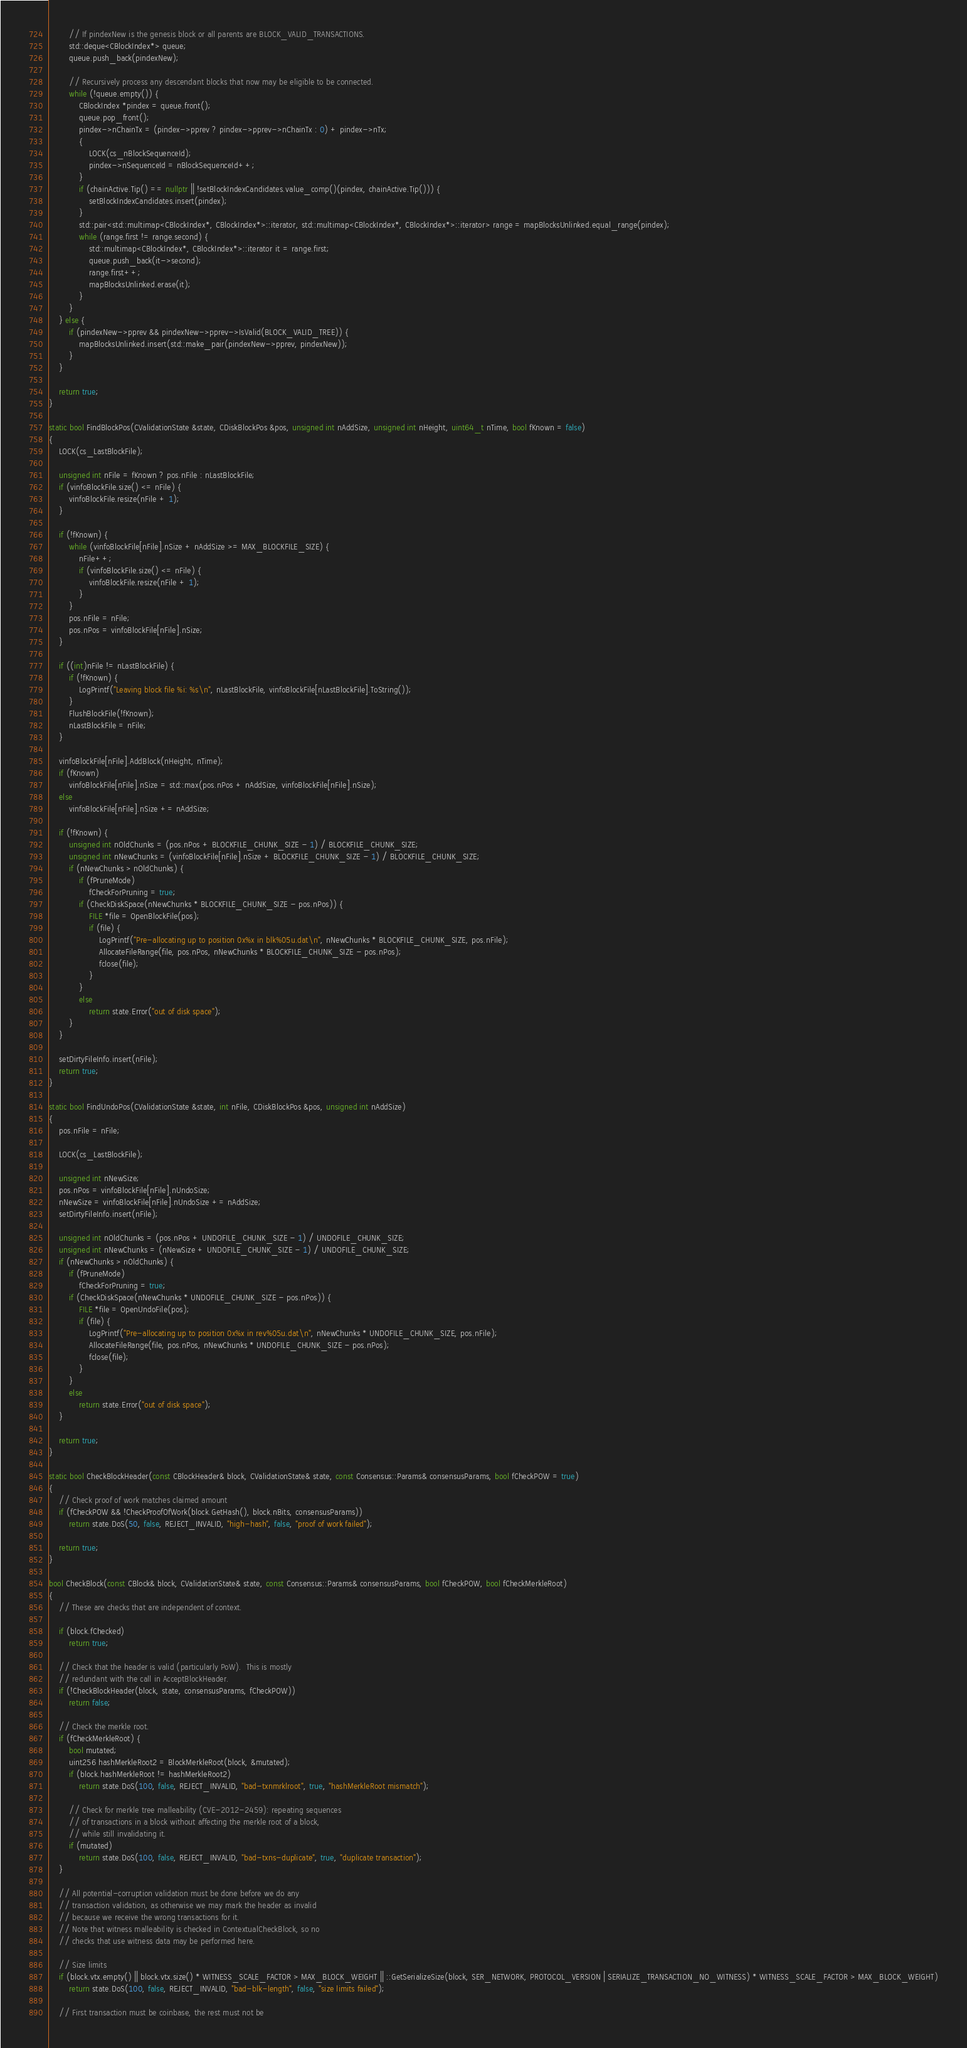<code> <loc_0><loc_0><loc_500><loc_500><_C++_>        // If pindexNew is the genesis block or all parents are BLOCK_VALID_TRANSACTIONS.
        std::deque<CBlockIndex*> queue;
        queue.push_back(pindexNew);

        // Recursively process any descendant blocks that now may be eligible to be connected.
        while (!queue.empty()) {
            CBlockIndex *pindex = queue.front();
            queue.pop_front();
            pindex->nChainTx = (pindex->pprev ? pindex->pprev->nChainTx : 0) + pindex->nTx;
            {
                LOCK(cs_nBlockSequenceId);
                pindex->nSequenceId = nBlockSequenceId++;
            }
            if (chainActive.Tip() == nullptr || !setBlockIndexCandidates.value_comp()(pindex, chainActive.Tip())) {
                setBlockIndexCandidates.insert(pindex);
            }
            std::pair<std::multimap<CBlockIndex*, CBlockIndex*>::iterator, std::multimap<CBlockIndex*, CBlockIndex*>::iterator> range = mapBlocksUnlinked.equal_range(pindex);
            while (range.first != range.second) {
                std::multimap<CBlockIndex*, CBlockIndex*>::iterator it = range.first;
                queue.push_back(it->second);
                range.first++;
                mapBlocksUnlinked.erase(it);
            }
        }
    } else {
        if (pindexNew->pprev && pindexNew->pprev->IsValid(BLOCK_VALID_TREE)) {
            mapBlocksUnlinked.insert(std::make_pair(pindexNew->pprev, pindexNew));
        }
    }

    return true;
}

static bool FindBlockPos(CValidationState &state, CDiskBlockPos &pos, unsigned int nAddSize, unsigned int nHeight, uint64_t nTime, bool fKnown = false)
{
    LOCK(cs_LastBlockFile);

    unsigned int nFile = fKnown ? pos.nFile : nLastBlockFile;
    if (vinfoBlockFile.size() <= nFile) {
        vinfoBlockFile.resize(nFile + 1);
    }

    if (!fKnown) {
        while (vinfoBlockFile[nFile].nSize + nAddSize >= MAX_BLOCKFILE_SIZE) {
            nFile++;
            if (vinfoBlockFile.size() <= nFile) {
                vinfoBlockFile.resize(nFile + 1);
            }
        }
        pos.nFile = nFile;
        pos.nPos = vinfoBlockFile[nFile].nSize;
    }

    if ((int)nFile != nLastBlockFile) {
        if (!fKnown) {
            LogPrintf("Leaving block file %i: %s\n", nLastBlockFile, vinfoBlockFile[nLastBlockFile].ToString());
        }
        FlushBlockFile(!fKnown);
        nLastBlockFile = nFile;
    }

    vinfoBlockFile[nFile].AddBlock(nHeight, nTime);
    if (fKnown)
        vinfoBlockFile[nFile].nSize = std::max(pos.nPos + nAddSize, vinfoBlockFile[nFile].nSize);
    else
        vinfoBlockFile[nFile].nSize += nAddSize;

    if (!fKnown) {
        unsigned int nOldChunks = (pos.nPos + BLOCKFILE_CHUNK_SIZE - 1) / BLOCKFILE_CHUNK_SIZE;
        unsigned int nNewChunks = (vinfoBlockFile[nFile].nSize + BLOCKFILE_CHUNK_SIZE - 1) / BLOCKFILE_CHUNK_SIZE;
        if (nNewChunks > nOldChunks) {
            if (fPruneMode)
                fCheckForPruning = true;
            if (CheckDiskSpace(nNewChunks * BLOCKFILE_CHUNK_SIZE - pos.nPos)) {
                FILE *file = OpenBlockFile(pos);
                if (file) {
                    LogPrintf("Pre-allocating up to position 0x%x in blk%05u.dat\n", nNewChunks * BLOCKFILE_CHUNK_SIZE, pos.nFile);
                    AllocateFileRange(file, pos.nPos, nNewChunks * BLOCKFILE_CHUNK_SIZE - pos.nPos);
                    fclose(file);
                }
            }
            else
                return state.Error("out of disk space");
        }
    }

    setDirtyFileInfo.insert(nFile);
    return true;
}

static bool FindUndoPos(CValidationState &state, int nFile, CDiskBlockPos &pos, unsigned int nAddSize)
{
    pos.nFile = nFile;

    LOCK(cs_LastBlockFile);

    unsigned int nNewSize;
    pos.nPos = vinfoBlockFile[nFile].nUndoSize;
    nNewSize = vinfoBlockFile[nFile].nUndoSize += nAddSize;
    setDirtyFileInfo.insert(nFile);

    unsigned int nOldChunks = (pos.nPos + UNDOFILE_CHUNK_SIZE - 1) / UNDOFILE_CHUNK_SIZE;
    unsigned int nNewChunks = (nNewSize + UNDOFILE_CHUNK_SIZE - 1) / UNDOFILE_CHUNK_SIZE;
    if (nNewChunks > nOldChunks) {
        if (fPruneMode)
            fCheckForPruning = true;
        if (CheckDiskSpace(nNewChunks * UNDOFILE_CHUNK_SIZE - pos.nPos)) {
            FILE *file = OpenUndoFile(pos);
            if (file) {
                LogPrintf("Pre-allocating up to position 0x%x in rev%05u.dat\n", nNewChunks * UNDOFILE_CHUNK_SIZE, pos.nFile);
                AllocateFileRange(file, pos.nPos, nNewChunks * UNDOFILE_CHUNK_SIZE - pos.nPos);
                fclose(file);
            }
        }
        else
            return state.Error("out of disk space");
    }

    return true;
}

static bool CheckBlockHeader(const CBlockHeader& block, CValidationState& state, const Consensus::Params& consensusParams, bool fCheckPOW = true)
{
    // Check proof of work matches claimed amount
    if (fCheckPOW && !CheckProofOfWork(block.GetHash(), block.nBits, consensusParams))
        return state.DoS(50, false, REJECT_INVALID, "high-hash", false, "proof of work failed");

    return true;
}

bool CheckBlock(const CBlock& block, CValidationState& state, const Consensus::Params& consensusParams, bool fCheckPOW, bool fCheckMerkleRoot)
{
    // These are checks that are independent of context.

    if (block.fChecked)
        return true;

    // Check that the header is valid (particularly PoW).  This is mostly
    // redundant with the call in AcceptBlockHeader.
    if (!CheckBlockHeader(block, state, consensusParams, fCheckPOW))
        return false;

    // Check the merkle root.
    if (fCheckMerkleRoot) {
        bool mutated;
        uint256 hashMerkleRoot2 = BlockMerkleRoot(block, &mutated);
        if (block.hashMerkleRoot != hashMerkleRoot2)
            return state.DoS(100, false, REJECT_INVALID, "bad-txnmrklroot", true, "hashMerkleRoot mismatch");

        // Check for merkle tree malleability (CVE-2012-2459): repeating sequences
        // of transactions in a block without affecting the merkle root of a block,
        // while still invalidating it.
        if (mutated)
            return state.DoS(100, false, REJECT_INVALID, "bad-txns-duplicate", true, "duplicate transaction");
    }

    // All potential-corruption validation must be done before we do any
    // transaction validation, as otherwise we may mark the header as invalid
    // because we receive the wrong transactions for it.
    // Note that witness malleability is checked in ContextualCheckBlock, so no
    // checks that use witness data may be performed here.

    // Size limits
    if (block.vtx.empty() || block.vtx.size() * WITNESS_SCALE_FACTOR > MAX_BLOCK_WEIGHT || ::GetSerializeSize(block, SER_NETWORK, PROTOCOL_VERSION | SERIALIZE_TRANSACTION_NO_WITNESS) * WITNESS_SCALE_FACTOR > MAX_BLOCK_WEIGHT)
        return state.DoS(100, false, REJECT_INVALID, "bad-blk-length", false, "size limits failed");

    // First transaction must be coinbase, the rest must not be</code> 